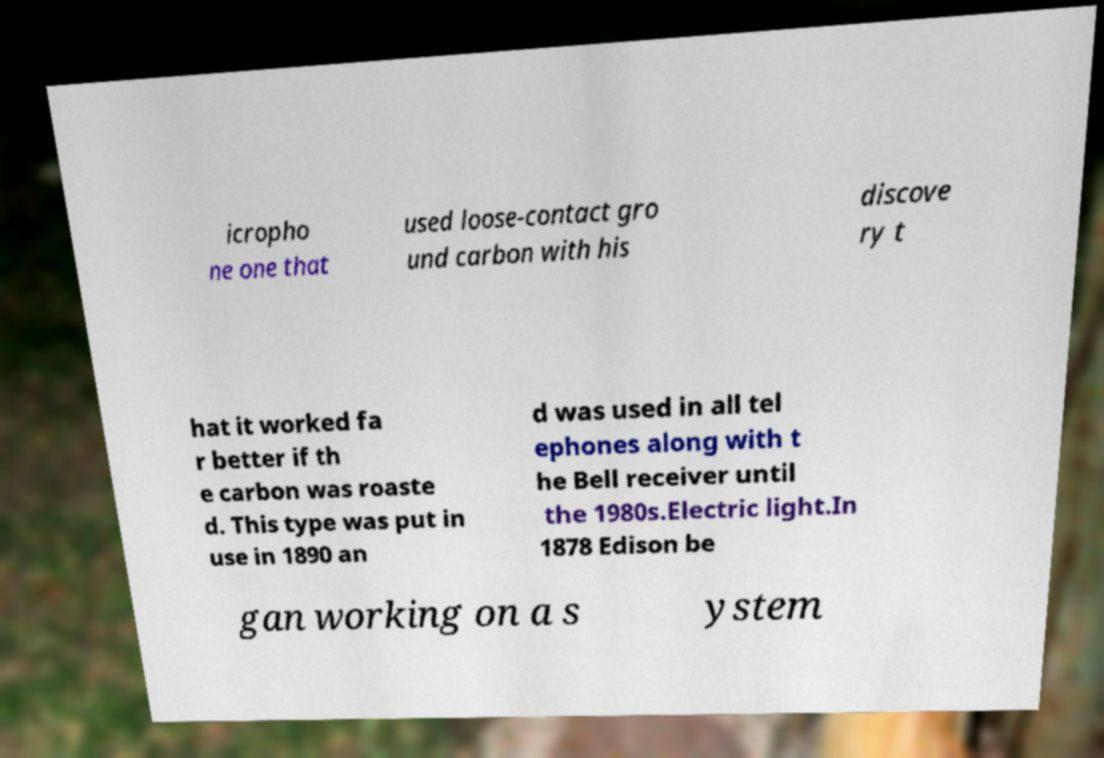Could you assist in decoding the text presented in this image and type it out clearly? icropho ne one that used loose-contact gro und carbon with his discove ry t hat it worked fa r better if th e carbon was roaste d. This type was put in use in 1890 an d was used in all tel ephones along with t he Bell receiver until the 1980s.Electric light.In 1878 Edison be gan working on a s ystem 